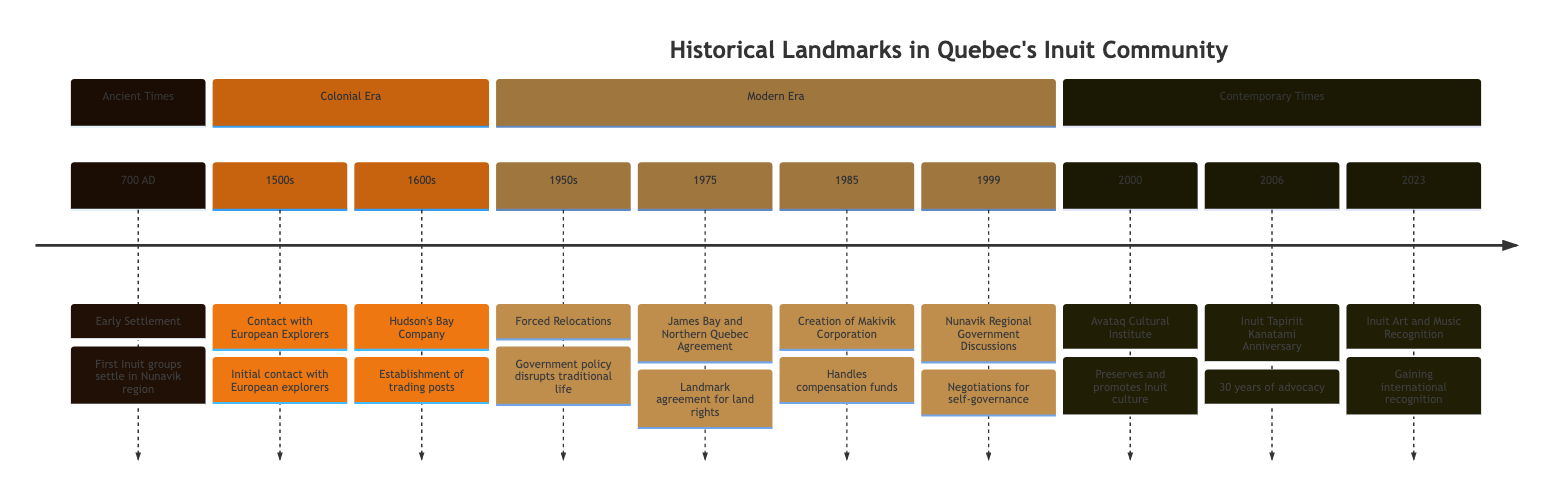What year did the early Inuit groups settle in Nunavik? The diagram shows that the event of early settlement took place in 700 AD. This can be found under the section labeled "Ancient Times," where the event is listed along with its corresponding year.
Answer: 700 AD What landmark agreement was made in 1975? Referring to the timeline, the specific event for the year 1975 is labeled as the "James Bay and Northern Quebec Agreement." It's shown in the section for the modern era and is a significant milestone for the Inuit community.
Answer: James Bay and Northern Quebec Agreement How many events are listed in the Colonial Era? The Colonial Era section of the timeline contains two distinct events: "Contact with European Explorers" in the 1500s and "Hudson's Bay Company" in the 1600s. By counting the events in this section, we find there are two.
Answer: 2 What was established in 2000 for Inuit culture? The timeline indicates that the "Avataq Cultural Institute" was formed in the year 2000. This event is placed under the section titled "Contemporary Times," focusing on the preservation and promotion of Inuit culture.
Answer: Avataq Cultural Institute What major disruption did Inuit families face in the 1950s? According to the timeline, the event listed for the 1950s is "Forced Relocations," which indicates a significant government policy that affected traditional life. This event is categorized under the modern era.
Answer: Forced Relocations How many years did Inuit Tapiriit Kanatami celebrate by 2006? The timeline explicitly states that Inuit Tapiriit Kanatami celebrated its 30th anniversary in 2006. To understand this, you can look at the event listed in the contemporary times section.
Answer: 30 years What event marks the beginning of negotiations for self-governance in Nunavik? The event corresponding to the year 1999 is significant as it marks the beginning of "Nunavik Regional Government Discussions." This can be found in the section titled "Modern Era," highlighting its importance to Inuit self-governance.
Answer: Nunavik Regional Government Discussions Which event in the timeline represents a recognition of Inuit arts in 2023? The timeline points out that in 2023, "Inuit Art and Music Recognition" is significant, indicating that Inuit musicians and artists from Quebec received both national and international acknowledgment. This is found in the section for contemporary times.
Answer: Inuit Art and Music Recognition 